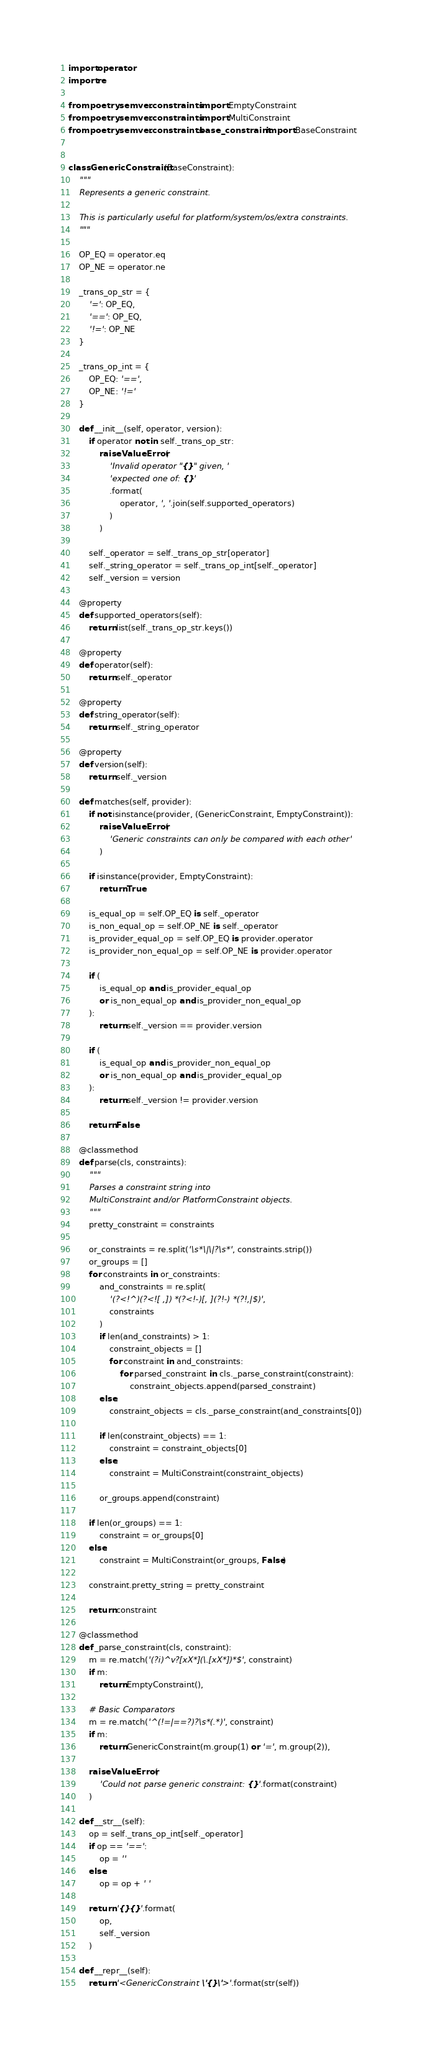Convert code to text. <code><loc_0><loc_0><loc_500><loc_500><_Python_>import operator
import re

from poetry.semver.constraints import EmptyConstraint
from poetry.semver.constraints import MultiConstraint
from poetry.semver.constraints.base_constraint import BaseConstraint


class GenericConstraint(BaseConstraint):
    """
    Represents a generic constraint.

    This is particularly useful for platform/system/os/extra constraints.
    """

    OP_EQ = operator.eq
    OP_NE = operator.ne

    _trans_op_str = {
        '=': OP_EQ,
        '==': OP_EQ,
        '!=': OP_NE
    }

    _trans_op_int = {
        OP_EQ: '==',
        OP_NE: '!='
    }

    def __init__(self, operator, version):
        if operator not in self._trans_op_str:
            raise ValueError(
                'Invalid operator "{}" given, '
                'expected one of: {}'
                .format(
                    operator, ', '.join(self.supported_operators)
                )
            )

        self._operator = self._trans_op_str[operator]
        self._string_operator = self._trans_op_int[self._operator]
        self._version = version

    @property
    def supported_operators(self):
        return list(self._trans_op_str.keys())

    @property
    def operator(self):
        return self._operator

    @property
    def string_operator(self):
        return self._string_operator

    @property
    def version(self):
        return self._version

    def matches(self, provider):
        if not isinstance(provider, (GenericConstraint, EmptyConstraint)):
            raise ValueError(
                'Generic constraints can only be compared with each other'
            )

        if isinstance(provider, EmptyConstraint):
            return True

        is_equal_op = self.OP_EQ is self._operator
        is_non_equal_op = self.OP_NE is self._operator
        is_provider_equal_op = self.OP_EQ is provider.operator
        is_provider_non_equal_op = self.OP_NE is provider.operator

        if (
            is_equal_op and is_provider_equal_op
            or is_non_equal_op and is_provider_non_equal_op
        ):
            return self._version == provider.version

        if (
            is_equal_op and is_provider_non_equal_op
            or is_non_equal_op and is_provider_equal_op
        ):
            return self._version != provider.version

        return False

    @classmethod
    def parse(cls, constraints):
        """
        Parses a constraint string into
        MultiConstraint and/or PlatformConstraint objects.
        """
        pretty_constraint = constraints

        or_constraints = re.split('\s*\|\|?\s*', constraints.strip())
        or_groups = []
        for constraints in or_constraints:
            and_constraints = re.split(
                '(?<!^)(?<![ ,]) *(?<!-)[, ](?!-) *(?!,|$)',
                constraints
            )
            if len(and_constraints) > 1:
                constraint_objects = []
                for constraint in and_constraints:
                    for parsed_constraint in cls._parse_constraint(constraint):
                        constraint_objects.append(parsed_constraint)
            else:
                constraint_objects = cls._parse_constraint(and_constraints[0])

            if len(constraint_objects) == 1:
                constraint = constraint_objects[0]
            else:
                constraint = MultiConstraint(constraint_objects)

            or_groups.append(constraint)

        if len(or_groups) == 1:
            constraint = or_groups[0]
        else:
            constraint = MultiConstraint(or_groups, False)

        constraint.pretty_string = pretty_constraint

        return constraint

    @classmethod
    def _parse_constraint(cls, constraint):
        m = re.match('(?i)^v?[xX*](\.[xX*])*$', constraint)
        if m:
            return EmptyConstraint(),

        # Basic Comparators
        m = re.match('^(!=|==?)?\s*(.*)', constraint)
        if m:
            return GenericConstraint(m.group(1) or '=', m.group(2)),

        raise ValueError(
            'Could not parse generic constraint: {}'.format(constraint)
        )

    def __str__(self):
        op = self._trans_op_int[self._operator]
        if op == '==':
            op = ''
        else:
            op = op + ' '

        return '{}{}'.format(
            op,
            self._version
        )

    def __repr__(self):
        return '<GenericConstraint \'{}\'>'.format(str(self))
</code> 